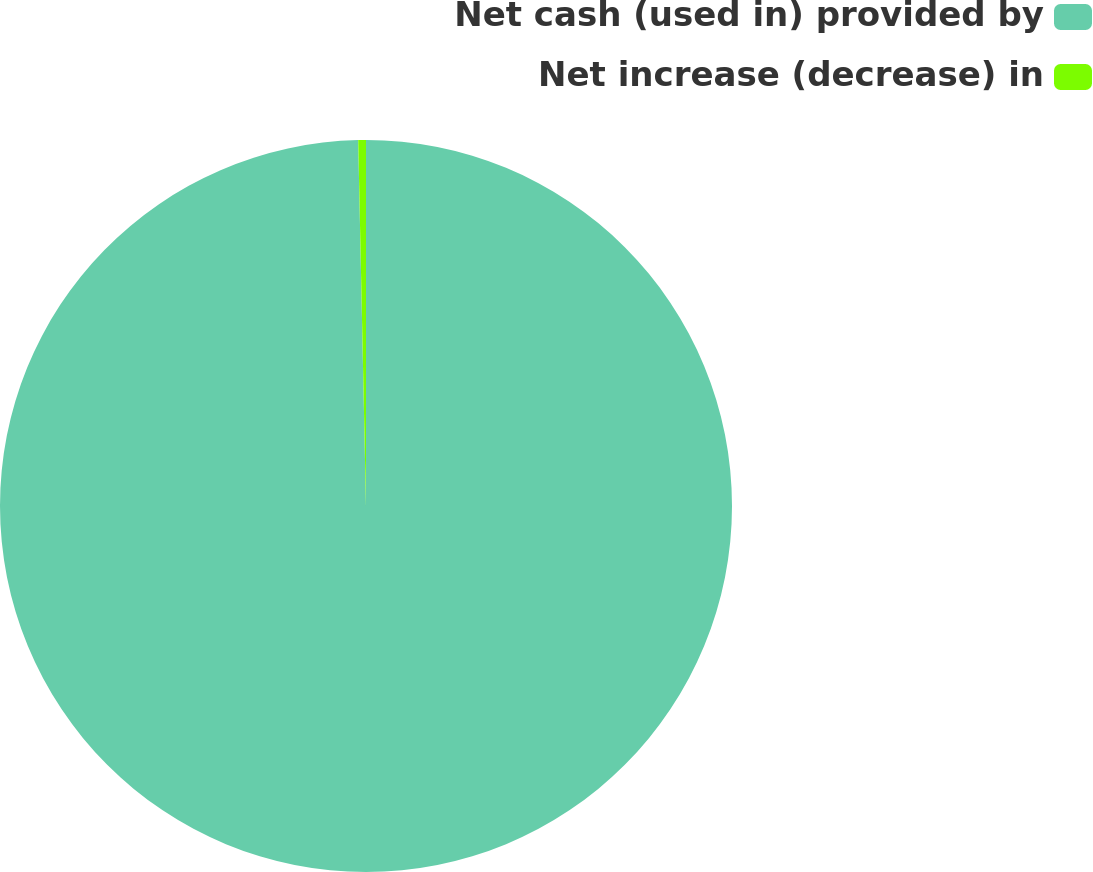Convert chart. <chart><loc_0><loc_0><loc_500><loc_500><pie_chart><fcel>Net cash (used in) provided by<fcel>Net increase (decrease) in<nl><fcel>99.66%<fcel>0.34%<nl></chart> 